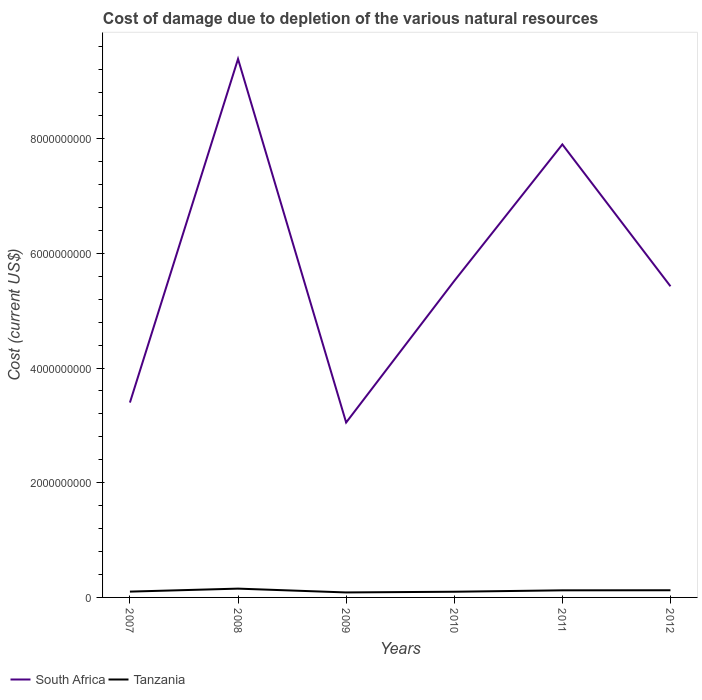Does the line corresponding to Tanzania intersect with the line corresponding to South Africa?
Your answer should be compact. No. Across all years, what is the maximum cost of damage caused due to the depletion of various natural resources in South Africa?
Your answer should be compact. 3.05e+09. What is the total cost of damage caused due to the depletion of various natural resources in Tanzania in the graph?
Ensure brevity in your answer.  -2.46e+07. What is the difference between the highest and the second highest cost of damage caused due to the depletion of various natural resources in South Africa?
Give a very brief answer. 6.34e+09. What is the difference between the highest and the lowest cost of damage caused due to the depletion of various natural resources in South Africa?
Your answer should be very brief. 2. Is the cost of damage caused due to the depletion of various natural resources in South Africa strictly greater than the cost of damage caused due to the depletion of various natural resources in Tanzania over the years?
Provide a succinct answer. No. How many lines are there?
Ensure brevity in your answer.  2. How many years are there in the graph?
Your answer should be very brief. 6. Are the values on the major ticks of Y-axis written in scientific E-notation?
Offer a terse response. No. Does the graph contain grids?
Keep it short and to the point. No. Where does the legend appear in the graph?
Offer a very short reply. Bottom left. What is the title of the graph?
Give a very brief answer. Cost of damage due to depletion of the various natural resources. Does "Dominican Republic" appear as one of the legend labels in the graph?
Ensure brevity in your answer.  No. What is the label or title of the X-axis?
Your answer should be compact. Years. What is the label or title of the Y-axis?
Provide a short and direct response. Cost (current US$). What is the Cost (current US$) in South Africa in 2007?
Provide a short and direct response. 3.40e+09. What is the Cost (current US$) of Tanzania in 2007?
Offer a very short reply. 1.01e+08. What is the Cost (current US$) of South Africa in 2008?
Provide a short and direct response. 9.39e+09. What is the Cost (current US$) in Tanzania in 2008?
Ensure brevity in your answer.  1.54e+08. What is the Cost (current US$) of South Africa in 2009?
Your answer should be very brief. 3.05e+09. What is the Cost (current US$) in Tanzania in 2009?
Make the answer very short. 8.69e+07. What is the Cost (current US$) of South Africa in 2010?
Provide a succinct answer. 5.52e+09. What is the Cost (current US$) of Tanzania in 2010?
Your response must be concise. 9.92e+07. What is the Cost (current US$) in South Africa in 2011?
Provide a short and direct response. 7.90e+09. What is the Cost (current US$) of Tanzania in 2011?
Ensure brevity in your answer.  1.24e+08. What is the Cost (current US$) in South Africa in 2012?
Offer a terse response. 5.43e+09. What is the Cost (current US$) in Tanzania in 2012?
Provide a succinct answer. 1.25e+08. Across all years, what is the maximum Cost (current US$) of South Africa?
Ensure brevity in your answer.  9.39e+09. Across all years, what is the maximum Cost (current US$) of Tanzania?
Keep it short and to the point. 1.54e+08. Across all years, what is the minimum Cost (current US$) in South Africa?
Offer a terse response. 3.05e+09. Across all years, what is the minimum Cost (current US$) in Tanzania?
Your answer should be compact. 8.69e+07. What is the total Cost (current US$) in South Africa in the graph?
Keep it short and to the point. 3.47e+1. What is the total Cost (current US$) in Tanzania in the graph?
Give a very brief answer. 6.90e+08. What is the difference between the Cost (current US$) in South Africa in 2007 and that in 2008?
Give a very brief answer. -5.99e+09. What is the difference between the Cost (current US$) of Tanzania in 2007 and that in 2008?
Keep it short and to the point. -5.22e+07. What is the difference between the Cost (current US$) of South Africa in 2007 and that in 2009?
Provide a short and direct response. 3.48e+08. What is the difference between the Cost (current US$) in Tanzania in 2007 and that in 2009?
Provide a short and direct response. 1.45e+07. What is the difference between the Cost (current US$) of South Africa in 2007 and that in 2010?
Your answer should be very brief. -2.12e+09. What is the difference between the Cost (current US$) of Tanzania in 2007 and that in 2010?
Your answer should be very brief. 2.15e+06. What is the difference between the Cost (current US$) in South Africa in 2007 and that in 2011?
Your response must be concise. -4.50e+09. What is the difference between the Cost (current US$) in Tanzania in 2007 and that in 2011?
Your response must be concise. -2.25e+07. What is the difference between the Cost (current US$) in South Africa in 2007 and that in 2012?
Your answer should be compact. -2.03e+09. What is the difference between the Cost (current US$) in Tanzania in 2007 and that in 2012?
Offer a terse response. -2.37e+07. What is the difference between the Cost (current US$) in South Africa in 2008 and that in 2009?
Your answer should be compact. 6.34e+09. What is the difference between the Cost (current US$) of Tanzania in 2008 and that in 2009?
Your answer should be compact. 6.67e+07. What is the difference between the Cost (current US$) in South Africa in 2008 and that in 2010?
Keep it short and to the point. 3.87e+09. What is the difference between the Cost (current US$) in Tanzania in 2008 and that in 2010?
Offer a terse response. 5.44e+07. What is the difference between the Cost (current US$) in South Africa in 2008 and that in 2011?
Keep it short and to the point. 1.49e+09. What is the difference between the Cost (current US$) of Tanzania in 2008 and that in 2011?
Offer a very short reply. 2.98e+07. What is the difference between the Cost (current US$) in South Africa in 2008 and that in 2012?
Give a very brief answer. 3.96e+09. What is the difference between the Cost (current US$) of Tanzania in 2008 and that in 2012?
Make the answer very short. 2.85e+07. What is the difference between the Cost (current US$) of South Africa in 2009 and that in 2010?
Provide a succinct answer. -2.47e+09. What is the difference between the Cost (current US$) of Tanzania in 2009 and that in 2010?
Your answer should be compact. -1.23e+07. What is the difference between the Cost (current US$) in South Africa in 2009 and that in 2011?
Your answer should be compact. -4.85e+09. What is the difference between the Cost (current US$) in Tanzania in 2009 and that in 2011?
Provide a succinct answer. -3.69e+07. What is the difference between the Cost (current US$) of South Africa in 2009 and that in 2012?
Your answer should be compact. -2.38e+09. What is the difference between the Cost (current US$) in Tanzania in 2009 and that in 2012?
Your answer should be very brief. -3.82e+07. What is the difference between the Cost (current US$) of South Africa in 2010 and that in 2011?
Make the answer very short. -2.38e+09. What is the difference between the Cost (current US$) of Tanzania in 2010 and that in 2011?
Your answer should be compact. -2.46e+07. What is the difference between the Cost (current US$) of South Africa in 2010 and that in 2012?
Offer a very short reply. 9.31e+07. What is the difference between the Cost (current US$) in Tanzania in 2010 and that in 2012?
Your answer should be very brief. -2.59e+07. What is the difference between the Cost (current US$) of South Africa in 2011 and that in 2012?
Keep it short and to the point. 2.47e+09. What is the difference between the Cost (current US$) in Tanzania in 2011 and that in 2012?
Your answer should be very brief. -1.27e+06. What is the difference between the Cost (current US$) in South Africa in 2007 and the Cost (current US$) in Tanzania in 2008?
Your response must be concise. 3.24e+09. What is the difference between the Cost (current US$) in South Africa in 2007 and the Cost (current US$) in Tanzania in 2009?
Give a very brief answer. 3.31e+09. What is the difference between the Cost (current US$) in South Africa in 2007 and the Cost (current US$) in Tanzania in 2010?
Your answer should be very brief. 3.30e+09. What is the difference between the Cost (current US$) in South Africa in 2007 and the Cost (current US$) in Tanzania in 2011?
Offer a terse response. 3.27e+09. What is the difference between the Cost (current US$) in South Africa in 2007 and the Cost (current US$) in Tanzania in 2012?
Provide a short and direct response. 3.27e+09. What is the difference between the Cost (current US$) of South Africa in 2008 and the Cost (current US$) of Tanzania in 2009?
Offer a very short reply. 9.30e+09. What is the difference between the Cost (current US$) of South Africa in 2008 and the Cost (current US$) of Tanzania in 2010?
Keep it short and to the point. 9.29e+09. What is the difference between the Cost (current US$) of South Africa in 2008 and the Cost (current US$) of Tanzania in 2011?
Your answer should be compact. 9.27e+09. What is the difference between the Cost (current US$) of South Africa in 2008 and the Cost (current US$) of Tanzania in 2012?
Ensure brevity in your answer.  9.26e+09. What is the difference between the Cost (current US$) of South Africa in 2009 and the Cost (current US$) of Tanzania in 2010?
Ensure brevity in your answer.  2.95e+09. What is the difference between the Cost (current US$) of South Africa in 2009 and the Cost (current US$) of Tanzania in 2011?
Offer a very short reply. 2.93e+09. What is the difference between the Cost (current US$) in South Africa in 2009 and the Cost (current US$) in Tanzania in 2012?
Keep it short and to the point. 2.92e+09. What is the difference between the Cost (current US$) in South Africa in 2010 and the Cost (current US$) in Tanzania in 2011?
Your response must be concise. 5.39e+09. What is the difference between the Cost (current US$) in South Africa in 2010 and the Cost (current US$) in Tanzania in 2012?
Give a very brief answer. 5.39e+09. What is the difference between the Cost (current US$) of South Africa in 2011 and the Cost (current US$) of Tanzania in 2012?
Provide a short and direct response. 7.77e+09. What is the average Cost (current US$) in South Africa per year?
Offer a very short reply. 5.78e+09. What is the average Cost (current US$) in Tanzania per year?
Give a very brief answer. 1.15e+08. In the year 2007, what is the difference between the Cost (current US$) in South Africa and Cost (current US$) in Tanzania?
Your response must be concise. 3.30e+09. In the year 2008, what is the difference between the Cost (current US$) of South Africa and Cost (current US$) of Tanzania?
Provide a succinct answer. 9.24e+09. In the year 2009, what is the difference between the Cost (current US$) of South Africa and Cost (current US$) of Tanzania?
Offer a terse response. 2.96e+09. In the year 2010, what is the difference between the Cost (current US$) in South Africa and Cost (current US$) in Tanzania?
Your answer should be very brief. 5.42e+09. In the year 2011, what is the difference between the Cost (current US$) of South Africa and Cost (current US$) of Tanzania?
Keep it short and to the point. 7.78e+09. In the year 2012, what is the difference between the Cost (current US$) of South Africa and Cost (current US$) of Tanzania?
Make the answer very short. 5.30e+09. What is the ratio of the Cost (current US$) of South Africa in 2007 to that in 2008?
Keep it short and to the point. 0.36. What is the ratio of the Cost (current US$) in Tanzania in 2007 to that in 2008?
Offer a terse response. 0.66. What is the ratio of the Cost (current US$) in South Africa in 2007 to that in 2009?
Offer a very short reply. 1.11. What is the ratio of the Cost (current US$) of Tanzania in 2007 to that in 2009?
Offer a very short reply. 1.17. What is the ratio of the Cost (current US$) of South Africa in 2007 to that in 2010?
Provide a succinct answer. 0.62. What is the ratio of the Cost (current US$) in Tanzania in 2007 to that in 2010?
Provide a short and direct response. 1.02. What is the ratio of the Cost (current US$) of South Africa in 2007 to that in 2011?
Give a very brief answer. 0.43. What is the ratio of the Cost (current US$) of Tanzania in 2007 to that in 2011?
Your answer should be compact. 0.82. What is the ratio of the Cost (current US$) of South Africa in 2007 to that in 2012?
Your answer should be compact. 0.63. What is the ratio of the Cost (current US$) in Tanzania in 2007 to that in 2012?
Provide a succinct answer. 0.81. What is the ratio of the Cost (current US$) in South Africa in 2008 to that in 2009?
Your answer should be very brief. 3.08. What is the ratio of the Cost (current US$) of Tanzania in 2008 to that in 2009?
Make the answer very short. 1.77. What is the ratio of the Cost (current US$) in South Africa in 2008 to that in 2010?
Ensure brevity in your answer.  1.7. What is the ratio of the Cost (current US$) of Tanzania in 2008 to that in 2010?
Your answer should be very brief. 1.55. What is the ratio of the Cost (current US$) of South Africa in 2008 to that in 2011?
Provide a short and direct response. 1.19. What is the ratio of the Cost (current US$) in Tanzania in 2008 to that in 2011?
Offer a very short reply. 1.24. What is the ratio of the Cost (current US$) of South Africa in 2008 to that in 2012?
Provide a succinct answer. 1.73. What is the ratio of the Cost (current US$) in Tanzania in 2008 to that in 2012?
Make the answer very short. 1.23. What is the ratio of the Cost (current US$) in South Africa in 2009 to that in 2010?
Your response must be concise. 0.55. What is the ratio of the Cost (current US$) in Tanzania in 2009 to that in 2010?
Ensure brevity in your answer.  0.88. What is the ratio of the Cost (current US$) of South Africa in 2009 to that in 2011?
Provide a succinct answer. 0.39. What is the ratio of the Cost (current US$) in Tanzania in 2009 to that in 2011?
Offer a terse response. 0.7. What is the ratio of the Cost (current US$) of South Africa in 2009 to that in 2012?
Your response must be concise. 0.56. What is the ratio of the Cost (current US$) of Tanzania in 2009 to that in 2012?
Give a very brief answer. 0.69. What is the ratio of the Cost (current US$) in South Africa in 2010 to that in 2011?
Offer a very short reply. 0.7. What is the ratio of the Cost (current US$) in Tanzania in 2010 to that in 2011?
Offer a terse response. 0.8. What is the ratio of the Cost (current US$) in South Africa in 2010 to that in 2012?
Offer a terse response. 1.02. What is the ratio of the Cost (current US$) of Tanzania in 2010 to that in 2012?
Your response must be concise. 0.79. What is the ratio of the Cost (current US$) in South Africa in 2011 to that in 2012?
Your answer should be compact. 1.46. What is the ratio of the Cost (current US$) of Tanzania in 2011 to that in 2012?
Provide a short and direct response. 0.99. What is the difference between the highest and the second highest Cost (current US$) in South Africa?
Your response must be concise. 1.49e+09. What is the difference between the highest and the second highest Cost (current US$) of Tanzania?
Your response must be concise. 2.85e+07. What is the difference between the highest and the lowest Cost (current US$) of South Africa?
Give a very brief answer. 6.34e+09. What is the difference between the highest and the lowest Cost (current US$) of Tanzania?
Your response must be concise. 6.67e+07. 